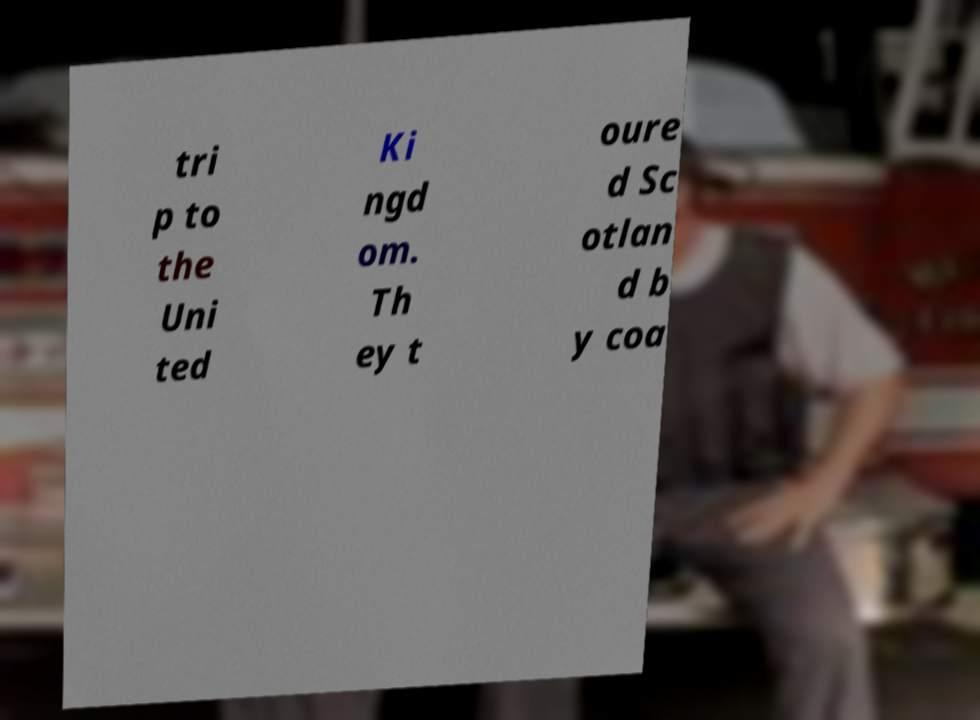What messages or text are displayed in this image? I need them in a readable, typed format. tri p to the Uni ted Ki ngd om. Th ey t oure d Sc otlan d b y coa 